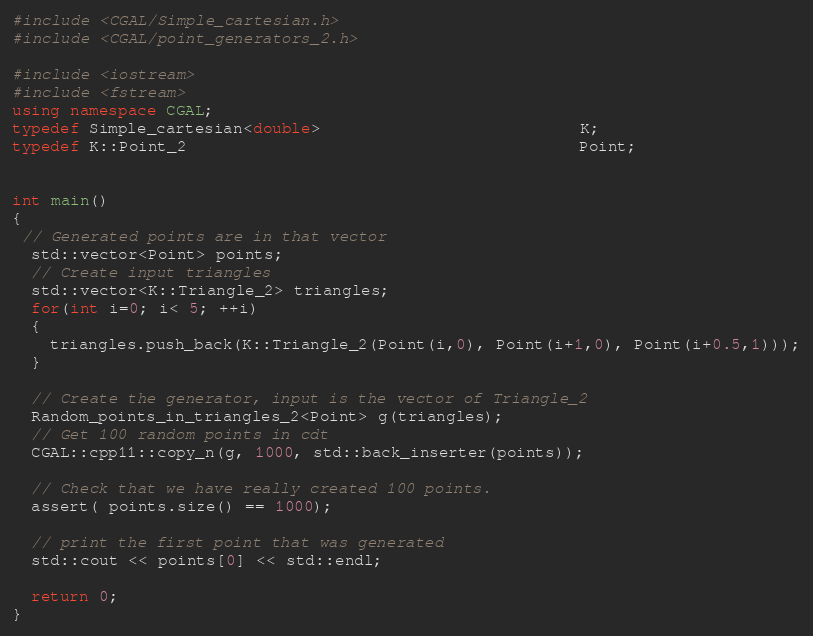<code> <loc_0><loc_0><loc_500><loc_500><_C++_>#include <CGAL/Simple_cartesian.h>
#include <CGAL/point_generators_2.h>

#include <iostream>
#include <fstream>
using namespace CGAL;
typedef Simple_cartesian<double>                           K;
typedef K::Point_2                                         Point;


int main()
{
 // Generated points are in that vector
  std::vector<Point> points;
  // Create input triangles
  std::vector<K::Triangle_2> triangles;
  for(int i=0; i< 5; ++i)
  {
    triangles.push_back(K::Triangle_2(Point(i,0), Point(i+1,0), Point(i+0.5,1)));
  }

  // Create the generator, input is the vector of Triangle_2
  Random_points_in_triangles_2<Point> g(triangles);
  // Get 100 random points in cdt
  CGAL::cpp11::copy_n(g, 1000, std::back_inserter(points));

  // Check that we have really created 100 points.
  assert( points.size() == 1000);

  // print the first point that was generated
  std::cout << points[0] << std::endl;

  return 0;
}


</code> 